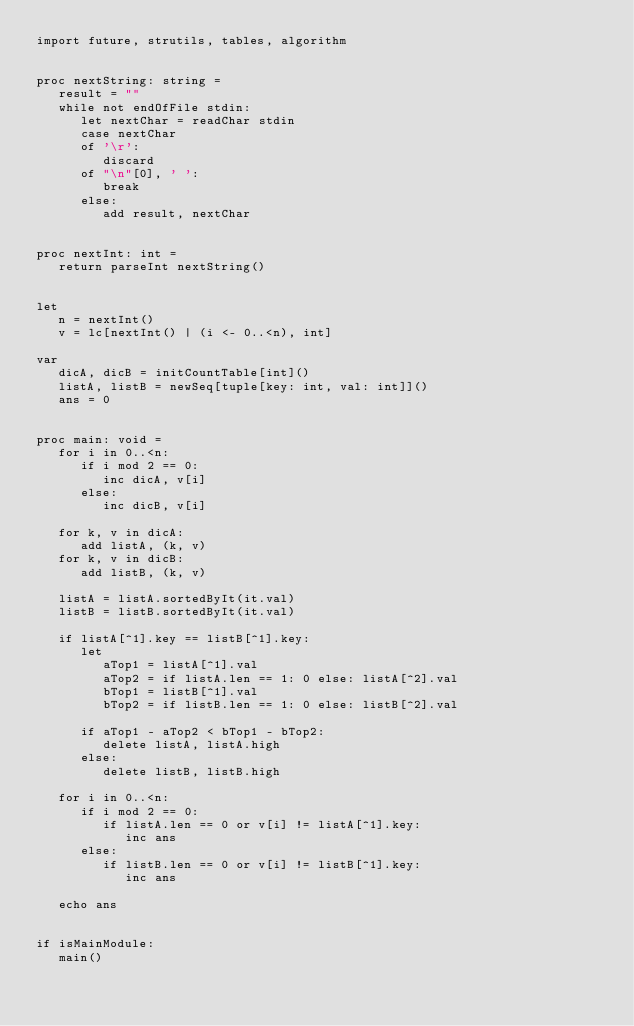Convert code to text. <code><loc_0><loc_0><loc_500><loc_500><_Nim_>import future, strutils, tables, algorithm


proc nextString: string =
   result = ""
   while not endOfFile stdin:
      let nextChar = readChar stdin
      case nextChar
      of '\r':
         discard
      of "\n"[0], ' ':
         break
      else:
         add result, nextChar


proc nextInt: int =
   return parseInt nextString()


let
   n = nextInt()
   v = lc[nextInt() | (i <- 0..<n), int]

var
   dicA, dicB = initCountTable[int]()
   listA, listB = newSeq[tuple[key: int, val: int]]()
   ans = 0


proc main: void =
   for i in 0..<n:
      if i mod 2 == 0:
         inc dicA, v[i]
      else:
         inc dicB, v[i]

   for k, v in dicA:
      add listA, (k, v)
   for k, v in dicB:
      add listB, (k, v)

   listA = listA.sortedByIt(it.val)
   listB = listB.sortedByIt(it.val)

   if listA[^1].key == listB[^1].key:
      let
         aTop1 = listA[^1].val
         aTop2 = if listA.len == 1: 0 else: listA[^2].val
         bTop1 = listB[^1].val
         bTop2 = if listB.len == 1: 0 else: listB[^2].val   

      if aTop1 - aTop2 < bTop1 - bTop2:
         delete listA, listA.high
      else:
         delete listB, listB.high

   for i in 0..<n:
      if i mod 2 == 0:
         if listA.len == 0 or v[i] != listA[^1].key:
            inc ans
      else:
         if listB.len == 0 or v[i] != listB[^1].key:
            inc ans

   echo ans


if isMainModule:
   main()
</code> 